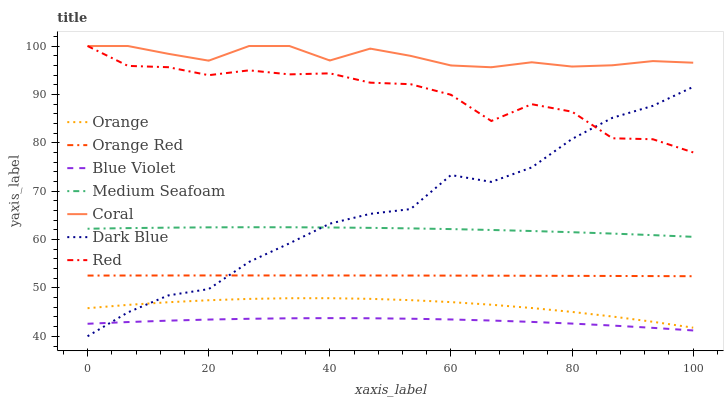Does Blue Violet have the minimum area under the curve?
Answer yes or no. Yes. Does Coral have the maximum area under the curve?
Answer yes or no. Yes. Does Medium Seafoam have the minimum area under the curve?
Answer yes or no. No. Does Medium Seafoam have the maximum area under the curve?
Answer yes or no. No. Is Orange Red the smoothest?
Answer yes or no. Yes. Is Red the roughest?
Answer yes or no. Yes. Is Medium Seafoam the smoothest?
Answer yes or no. No. Is Medium Seafoam the roughest?
Answer yes or no. No. Does Dark Blue have the lowest value?
Answer yes or no. Yes. Does Medium Seafoam have the lowest value?
Answer yes or no. No. Does Red have the highest value?
Answer yes or no. Yes. Does Medium Seafoam have the highest value?
Answer yes or no. No. Is Orange less than Orange Red?
Answer yes or no. Yes. Is Red greater than Orange?
Answer yes or no. Yes. Does Coral intersect Red?
Answer yes or no. Yes. Is Coral less than Red?
Answer yes or no. No. Is Coral greater than Red?
Answer yes or no. No. Does Orange intersect Orange Red?
Answer yes or no. No. 